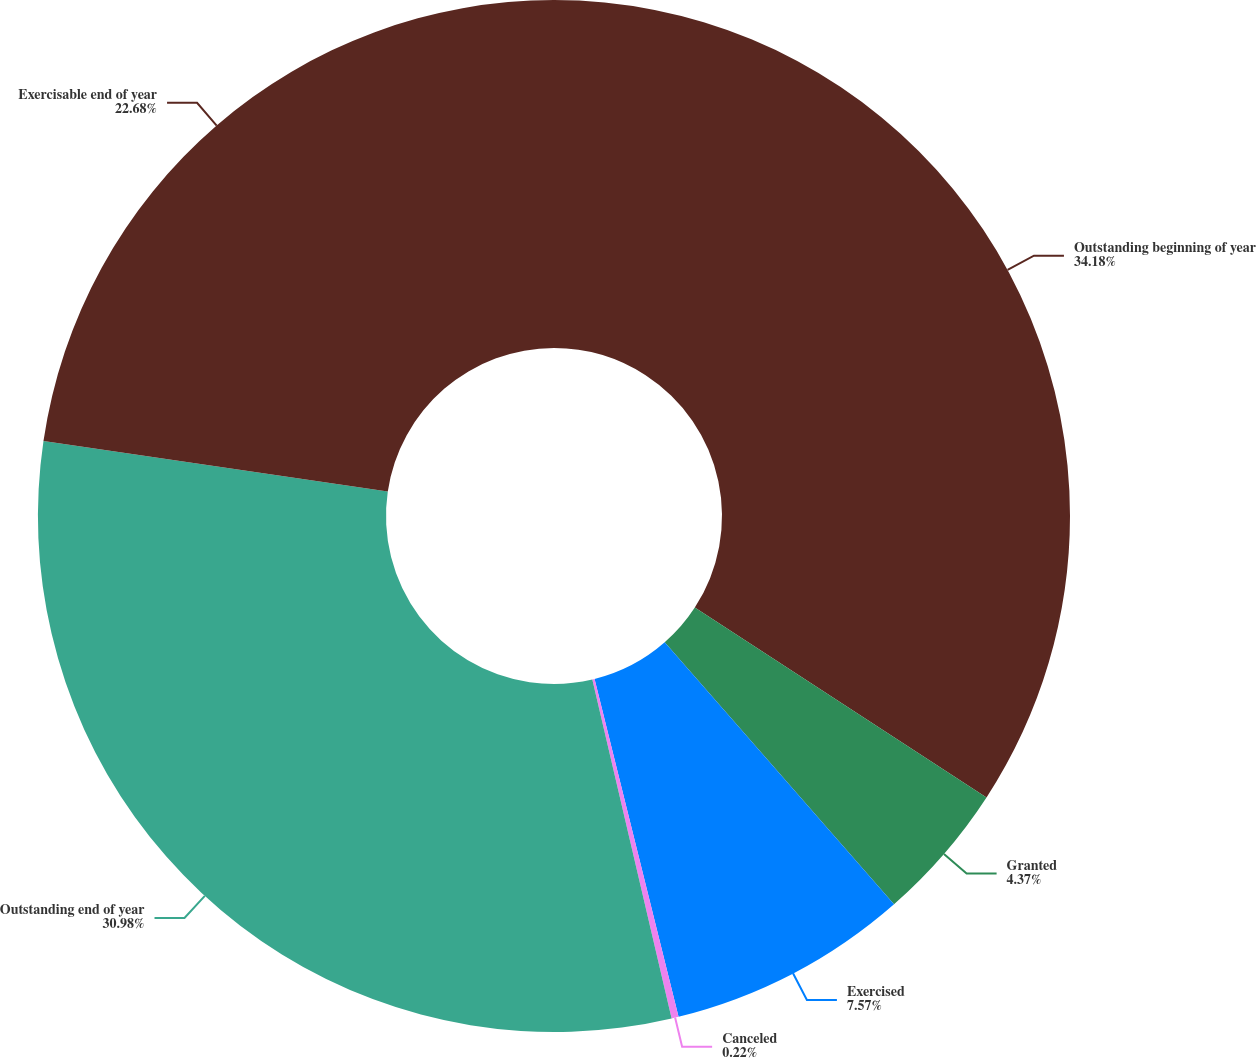Convert chart to OTSL. <chart><loc_0><loc_0><loc_500><loc_500><pie_chart><fcel>Outstanding beginning of year<fcel>Granted<fcel>Exercised<fcel>Canceled<fcel>Outstanding end of year<fcel>Exercisable end of year<nl><fcel>34.18%<fcel>4.37%<fcel>7.57%<fcel>0.22%<fcel>30.98%<fcel>22.68%<nl></chart> 